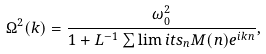<formula> <loc_0><loc_0><loc_500><loc_500>\Omega ^ { 2 } ( { k } ) = \frac { \omega _ { 0 } ^ { 2 } } { 1 + L ^ { - 1 } \sum \lim i t s _ { n } M ( { n } ) e ^ { i k n } } ,</formula> 